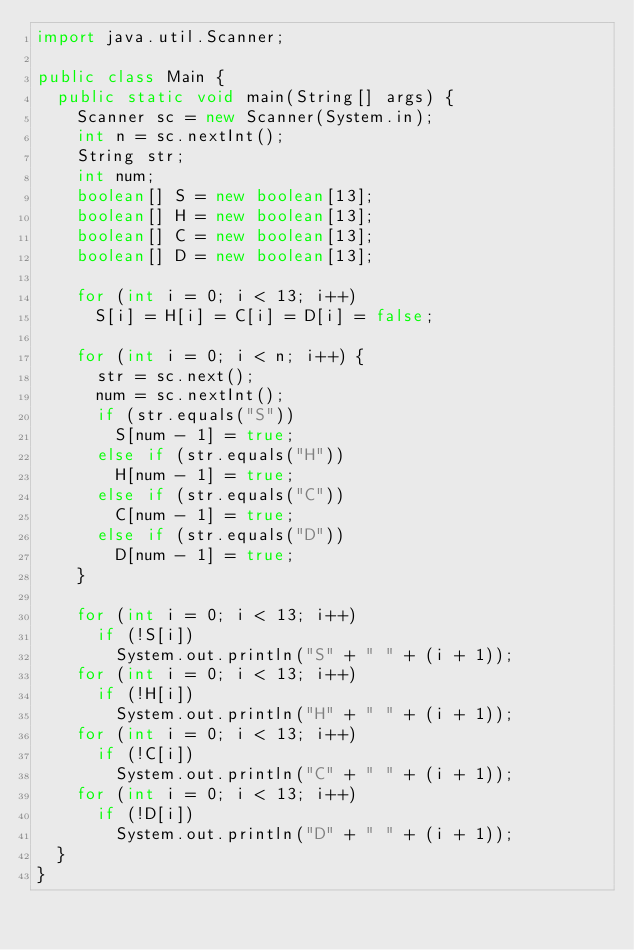Convert code to text. <code><loc_0><loc_0><loc_500><loc_500><_Java_>import java.util.Scanner;

public class Main {
  public static void main(String[] args) {
    Scanner sc = new Scanner(System.in);
    int n = sc.nextInt();
    String str;
    int num;
    boolean[] S = new boolean[13];
    boolean[] H = new boolean[13];
    boolean[] C = new boolean[13];
    boolean[] D = new boolean[13];

    for (int i = 0; i < 13; i++)
      S[i] = H[i] = C[i] = D[i] = false;

    for (int i = 0; i < n; i++) {
      str = sc.next();
      num = sc.nextInt();
      if (str.equals("S"))
        S[num - 1] = true;
      else if (str.equals("H"))
        H[num - 1] = true;
      else if (str.equals("C"))
        C[num - 1] = true;
      else if (str.equals("D"))
        D[num - 1] = true;
    }

    for (int i = 0; i < 13; i++)
      if (!S[i])
        System.out.println("S" + " " + (i + 1));
    for (int i = 0; i < 13; i++)
      if (!H[i])
        System.out.println("H" + " " + (i + 1));
    for (int i = 0; i < 13; i++)
      if (!C[i])
        System.out.println("C" + " " + (i + 1));
    for (int i = 0; i < 13; i++)
      if (!D[i])
        System.out.println("D" + " " + (i + 1));
  }
}</code> 